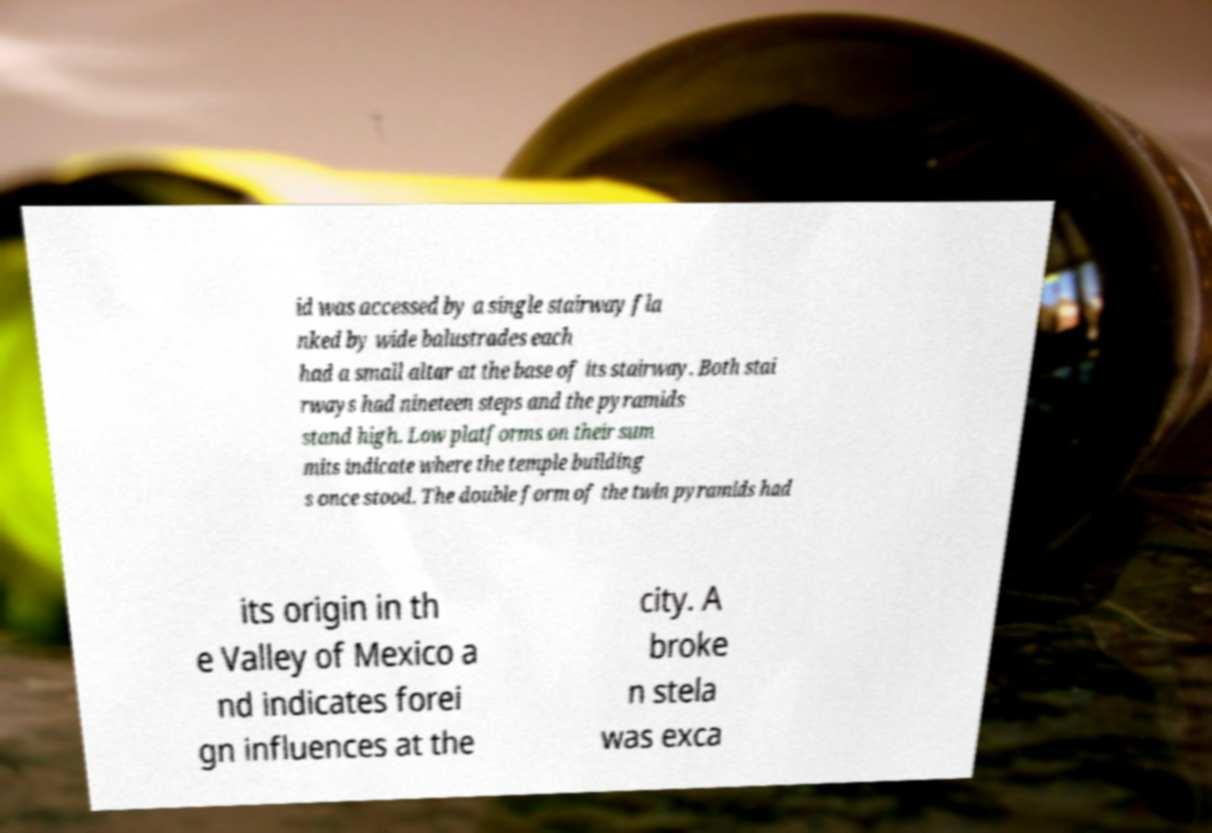What messages or text are displayed in this image? I need them in a readable, typed format. id was accessed by a single stairway fla nked by wide balustrades each had a small altar at the base of its stairway. Both stai rways had nineteen steps and the pyramids stand high. Low platforms on their sum mits indicate where the temple building s once stood. The double form of the twin pyramids had its origin in th e Valley of Mexico a nd indicates forei gn influences at the city. A broke n stela was exca 